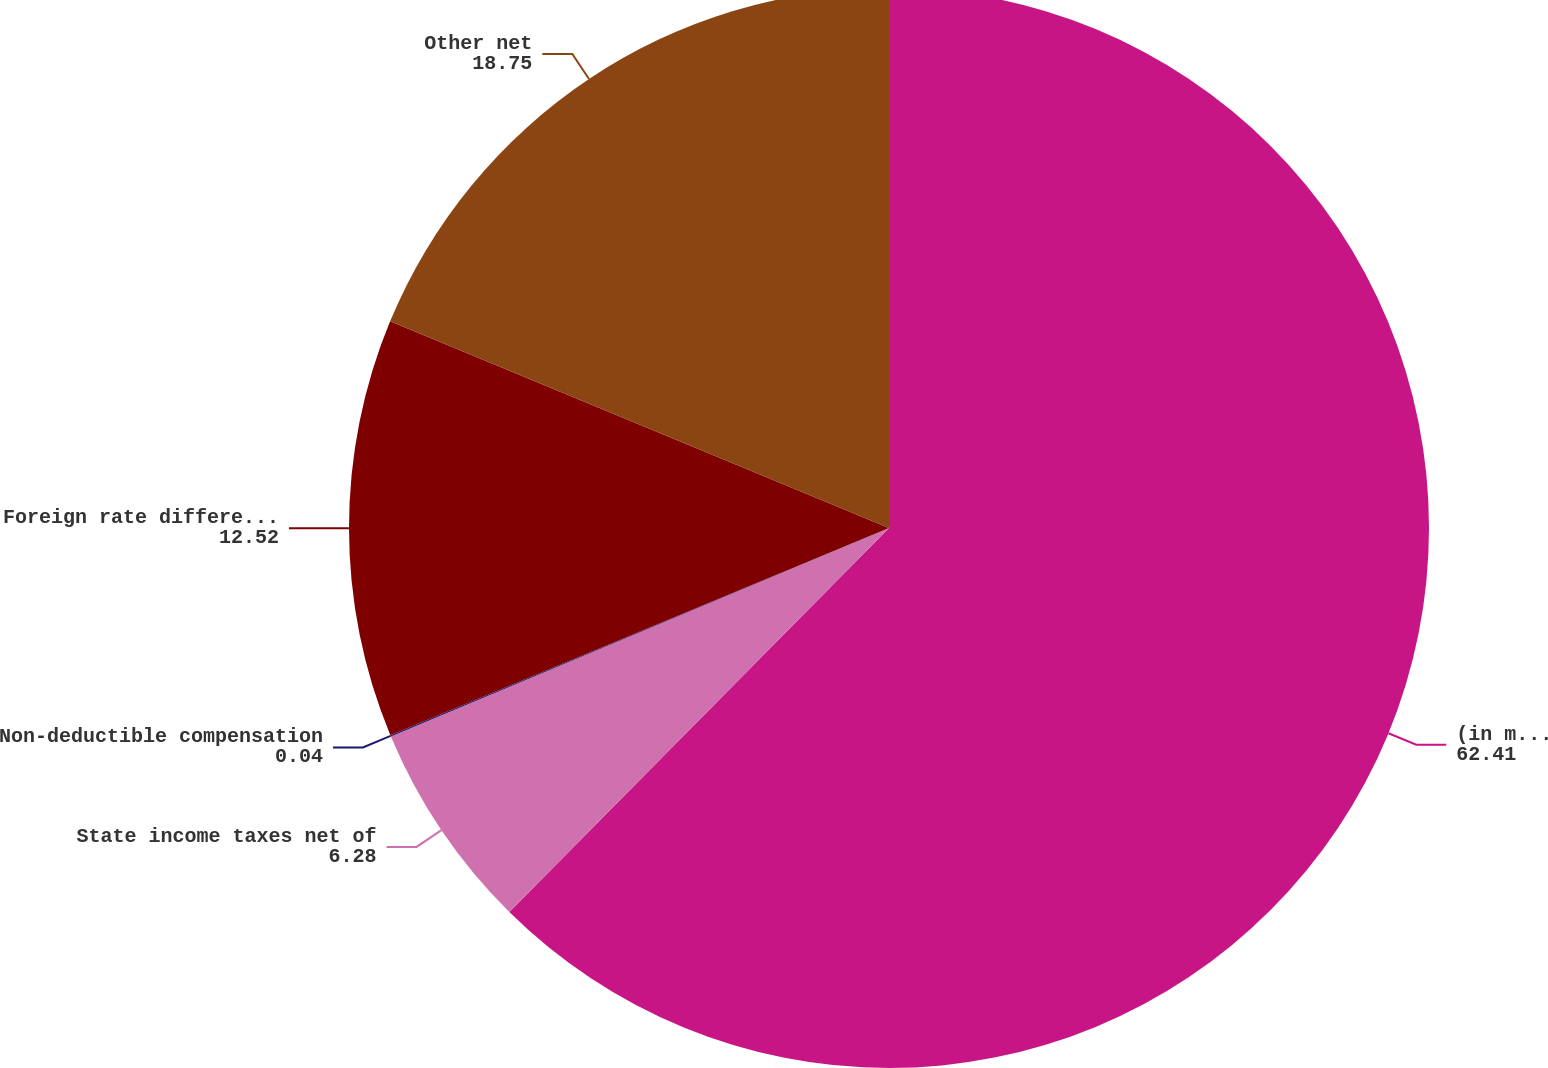Convert chart to OTSL. <chart><loc_0><loc_0><loc_500><loc_500><pie_chart><fcel>(in millions except<fcel>State income taxes net of<fcel>Non-deductible compensation<fcel>Foreign rate differential<fcel>Other net<nl><fcel>62.41%<fcel>6.28%<fcel>0.04%<fcel>12.52%<fcel>18.75%<nl></chart> 